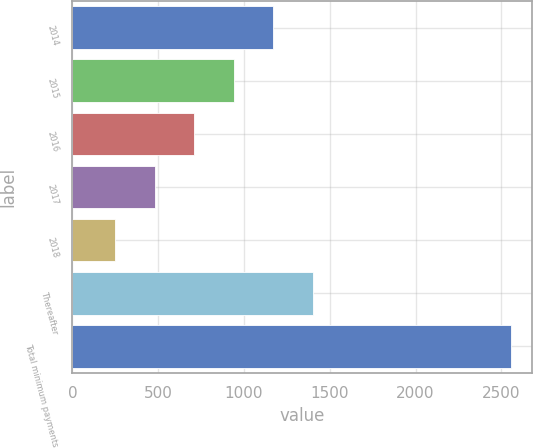Convert chart to OTSL. <chart><loc_0><loc_0><loc_500><loc_500><bar_chart><fcel>2014<fcel>2015<fcel>2016<fcel>2017<fcel>2018<fcel>Thereafter<fcel>Total minimum payments<nl><fcel>1171.6<fcel>941.2<fcel>710.8<fcel>480.4<fcel>250<fcel>1402<fcel>2554<nl></chart> 